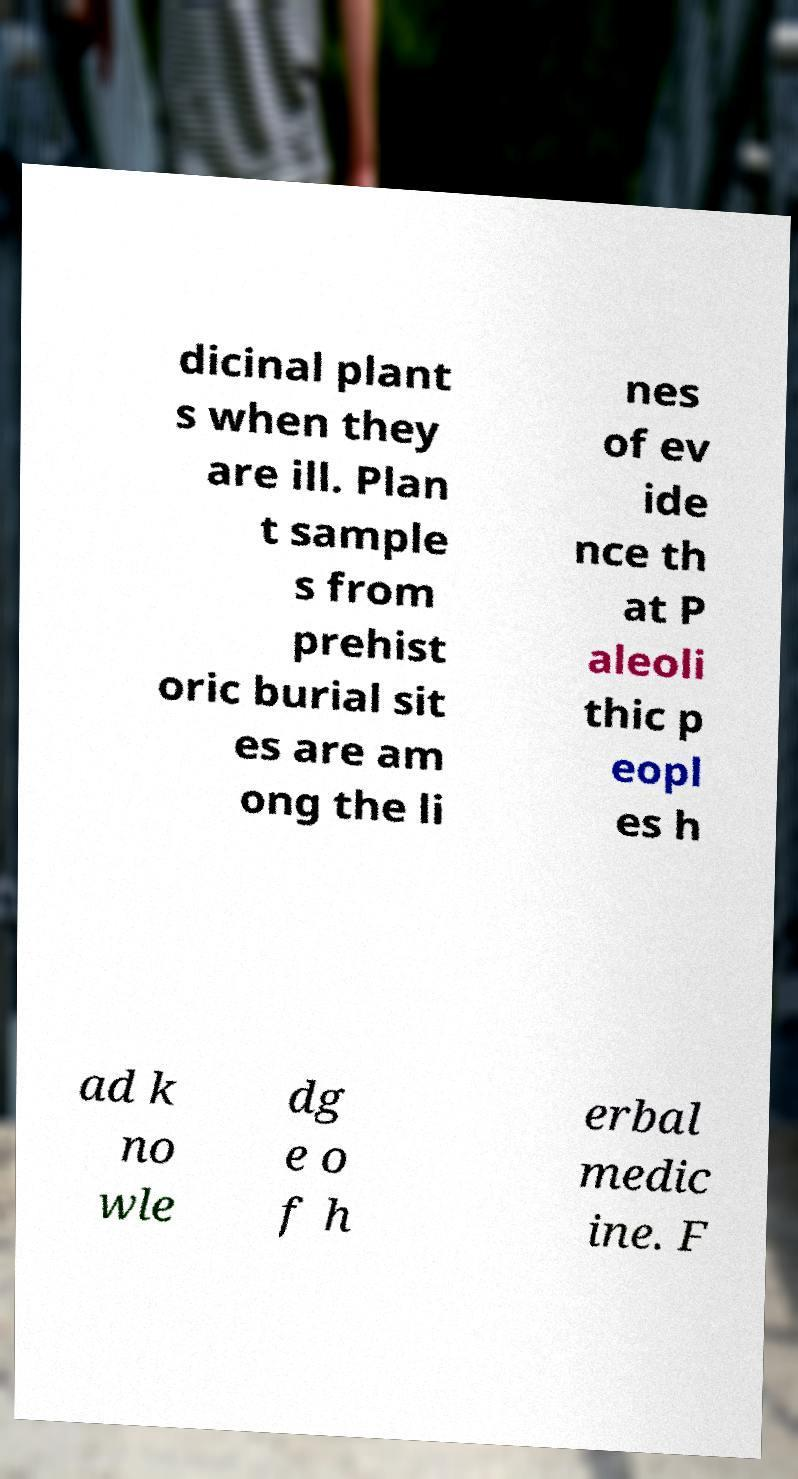I need the written content from this picture converted into text. Can you do that? dicinal plant s when they are ill. Plan t sample s from prehist oric burial sit es are am ong the li nes of ev ide nce th at P aleoli thic p eopl es h ad k no wle dg e o f h erbal medic ine. F 